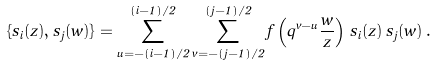Convert formula to latex. <formula><loc_0><loc_0><loc_500><loc_500>\{ s _ { i } ( z ) , s _ { j } ( w ) \} = \sum _ { u = - ( i - 1 ) / 2 } ^ { ( i - 1 ) / 2 } \sum _ { v = - ( j - 1 ) / 2 } ^ { ( j - 1 ) / 2 } f \left ( q ^ { v - u } \frac { w } { z } \right ) \, s _ { i } ( z ) \, s _ { j } ( w ) \, .</formula> 